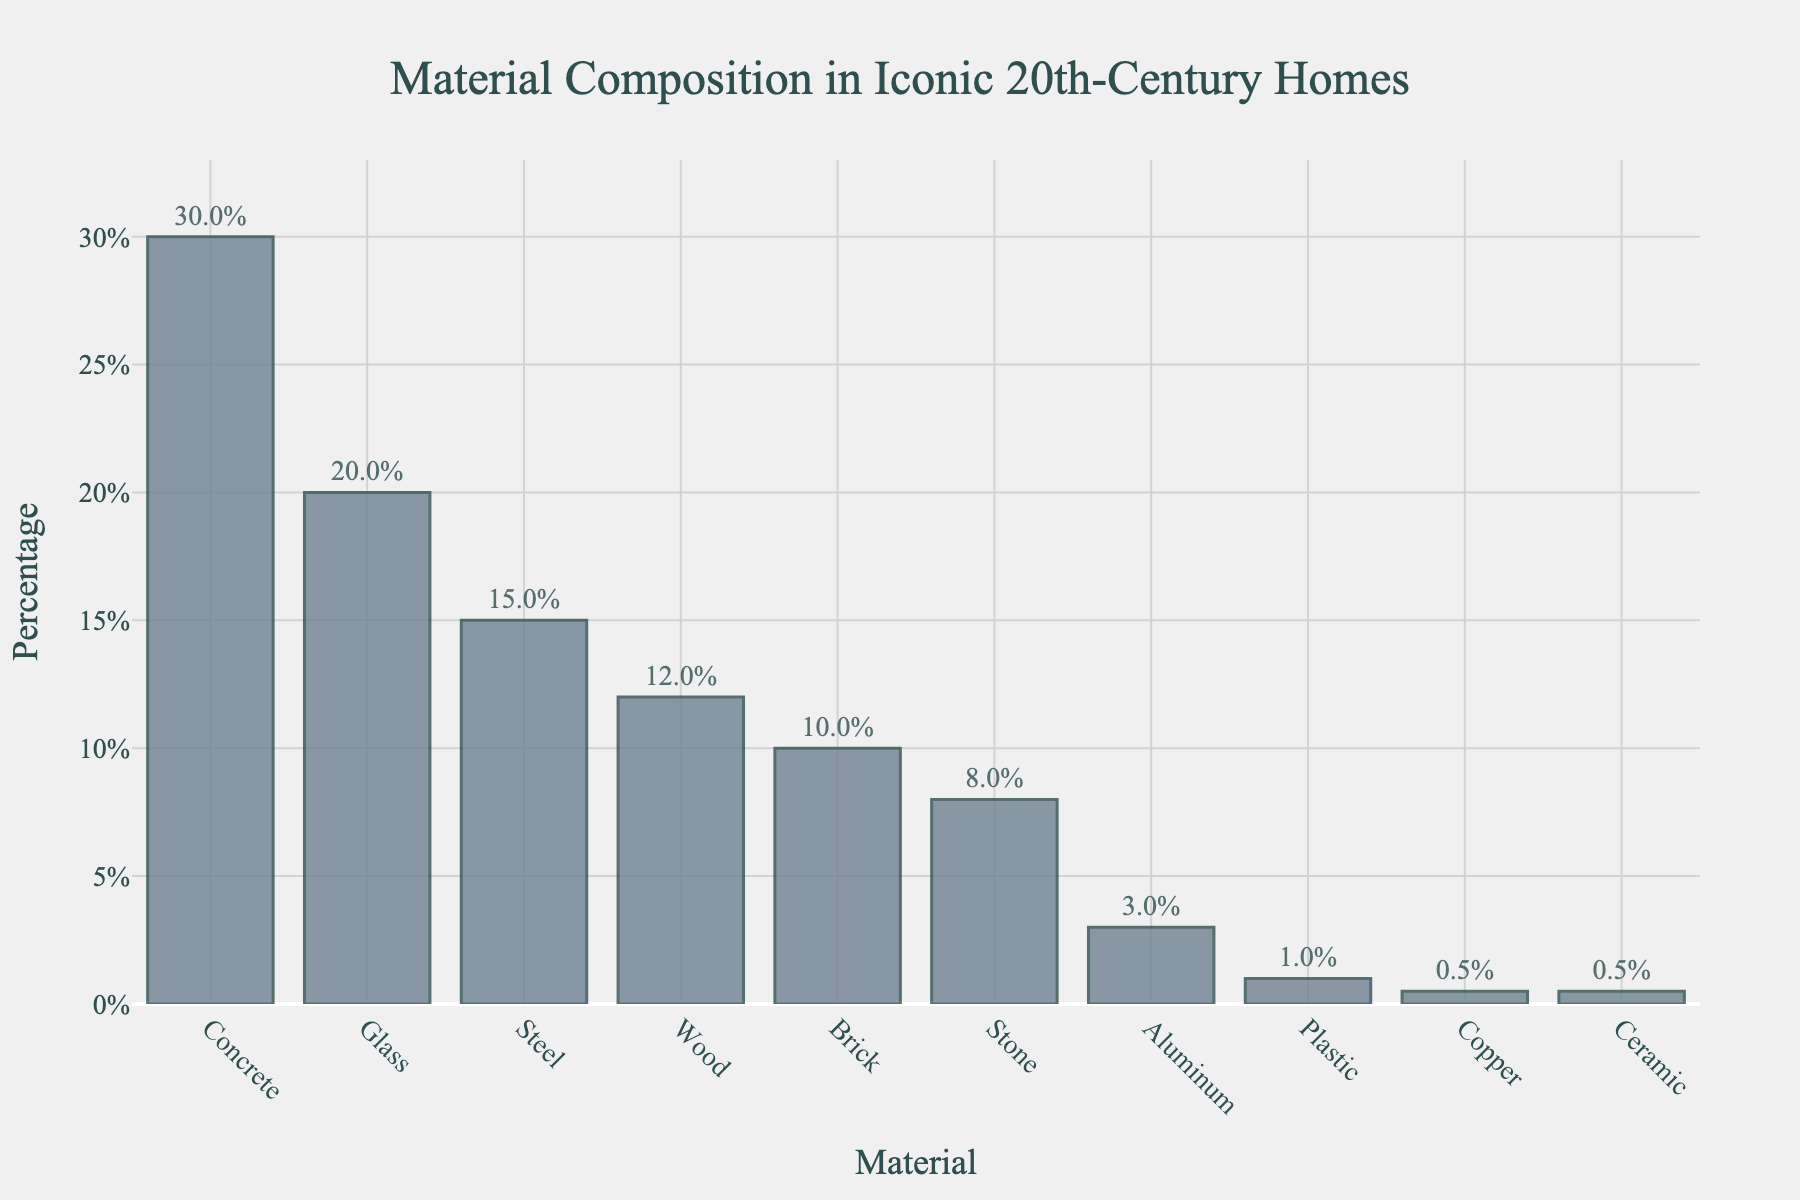What are the top three most used materials in iconic 20th-century homes? The figure shows the percentage breakdown of materials used. The top three materials by percentage are Concrete with 30%, Glass with 20%, and Steel with 15%.
Answer: Concrete, Glass, Steel Which material is used the least, and what is its percentage? The figure lists the materials from highest to lowest percentage. The material used the least is Ceramic, with a percentage of 0.5%.
Answer: Ceramic, 0.5% What is the combined percentage of Wood, Brick, and Stone? The percentages for Wood, Brick, and Stone are listed as 12%, 10%, and 8% respectively. The combined percentage is calculated as 12 + 10 + 8 = 30%.
Answer: 30% Is the percentage of Glass greater than that of Steel and Wood combined? The percentage of Glass is 20%. The combined percentage of Steel and Wood is 15% + 12% = 27%. Therefore, Glass is not greater than Steel and Wood combined.
Answer: No How does the percentage of Aluminum compare to that of Stone? The percentage for Aluminum is 3% and for Stone is 8%. Aluminum is used less than Stone.
Answer: Less Which material has approximately double the percentage of Wood? Wood has a percentage of 12%. The material with approximately double this is Concrete, at 30%.
Answer: Concrete What is the difference in percentage between the most and least used materials? The most used material is Concrete at 30%, and the least used material is Ceramic at 0.5%. The difference is 30 - 0.5 = 29.5%.
Answer: 29.5% Which material comes third in terms of usage percentage, and what is its value? The third material is listed after Concrete and Glass. According to the figure, Steel is third with a usage percentage of 15%.
Answer: Steel, 15% What fraction of the materials have a usage percentage of less than 10%? The materials with less than 10% usage are Brick (10%), Stone (8%), Aluminum (3%), Plastic (1%), Copper (0.5%), and Ceramic (0.5%). The total number of materials listed is 10. Therefore, 6 out of 10 materials have a percentage of less than 10%, giving a fraction of 6/10 or 3/5.
Answer: 3/5 How much higher is the percentage of Concrete compared to the combined percentage of Copper and Ceramic? The percentage of Concrete is 30%, while the combined percentage of Copper and Ceramic is 0.5% + 0.5% = 1%. Therefore, Concrete is 30 - 1 = 29% higher.
Answer: 29% higher 